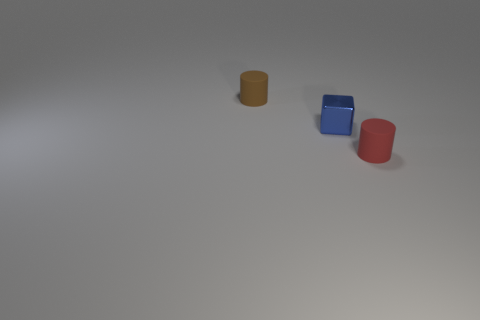Subtract all brown cylinders. How many cylinders are left? 1 Subtract all cubes. How many objects are left? 2 Add 1 rubber cylinders. How many objects exist? 4 Subtract 0 purple blocks. How many objects are left? 3 Subtract all red cubes. Subtract all red spheres. How many cubes are left? 1 Subtract all big blue matte things. Subtract all tiny brown cylinders. How many objects are left? 2 Add 3 shiny things. How many shiny things are left? 4 Add 3 tiny brown rubber things. How many tiny brown rubber things exist? 4 